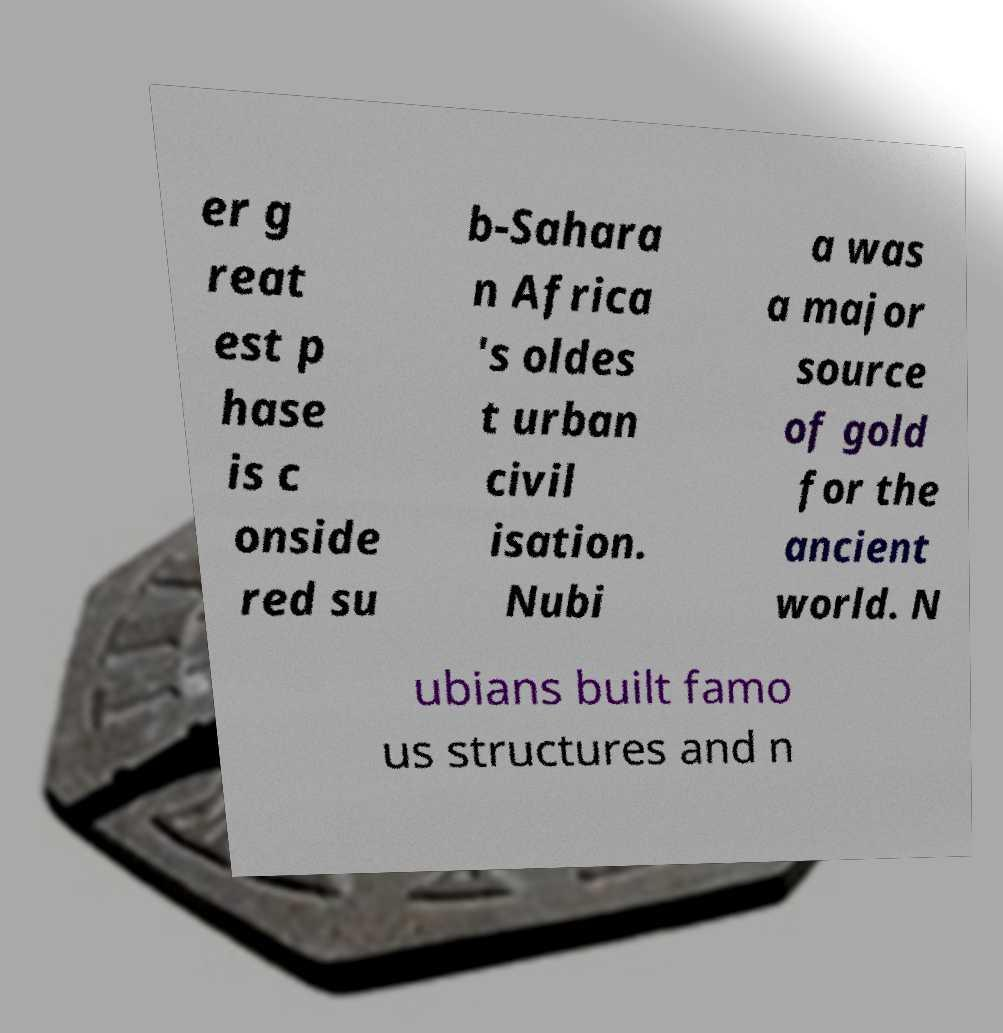Can you accurately transcribe the text from the provided image for me? er g reat est p hase is c onside red su b-Sahara n Africa 's oldes t urban civil isation. Nubi a was a major source of gold for the ancient world. N ubians built famo us structures and n 